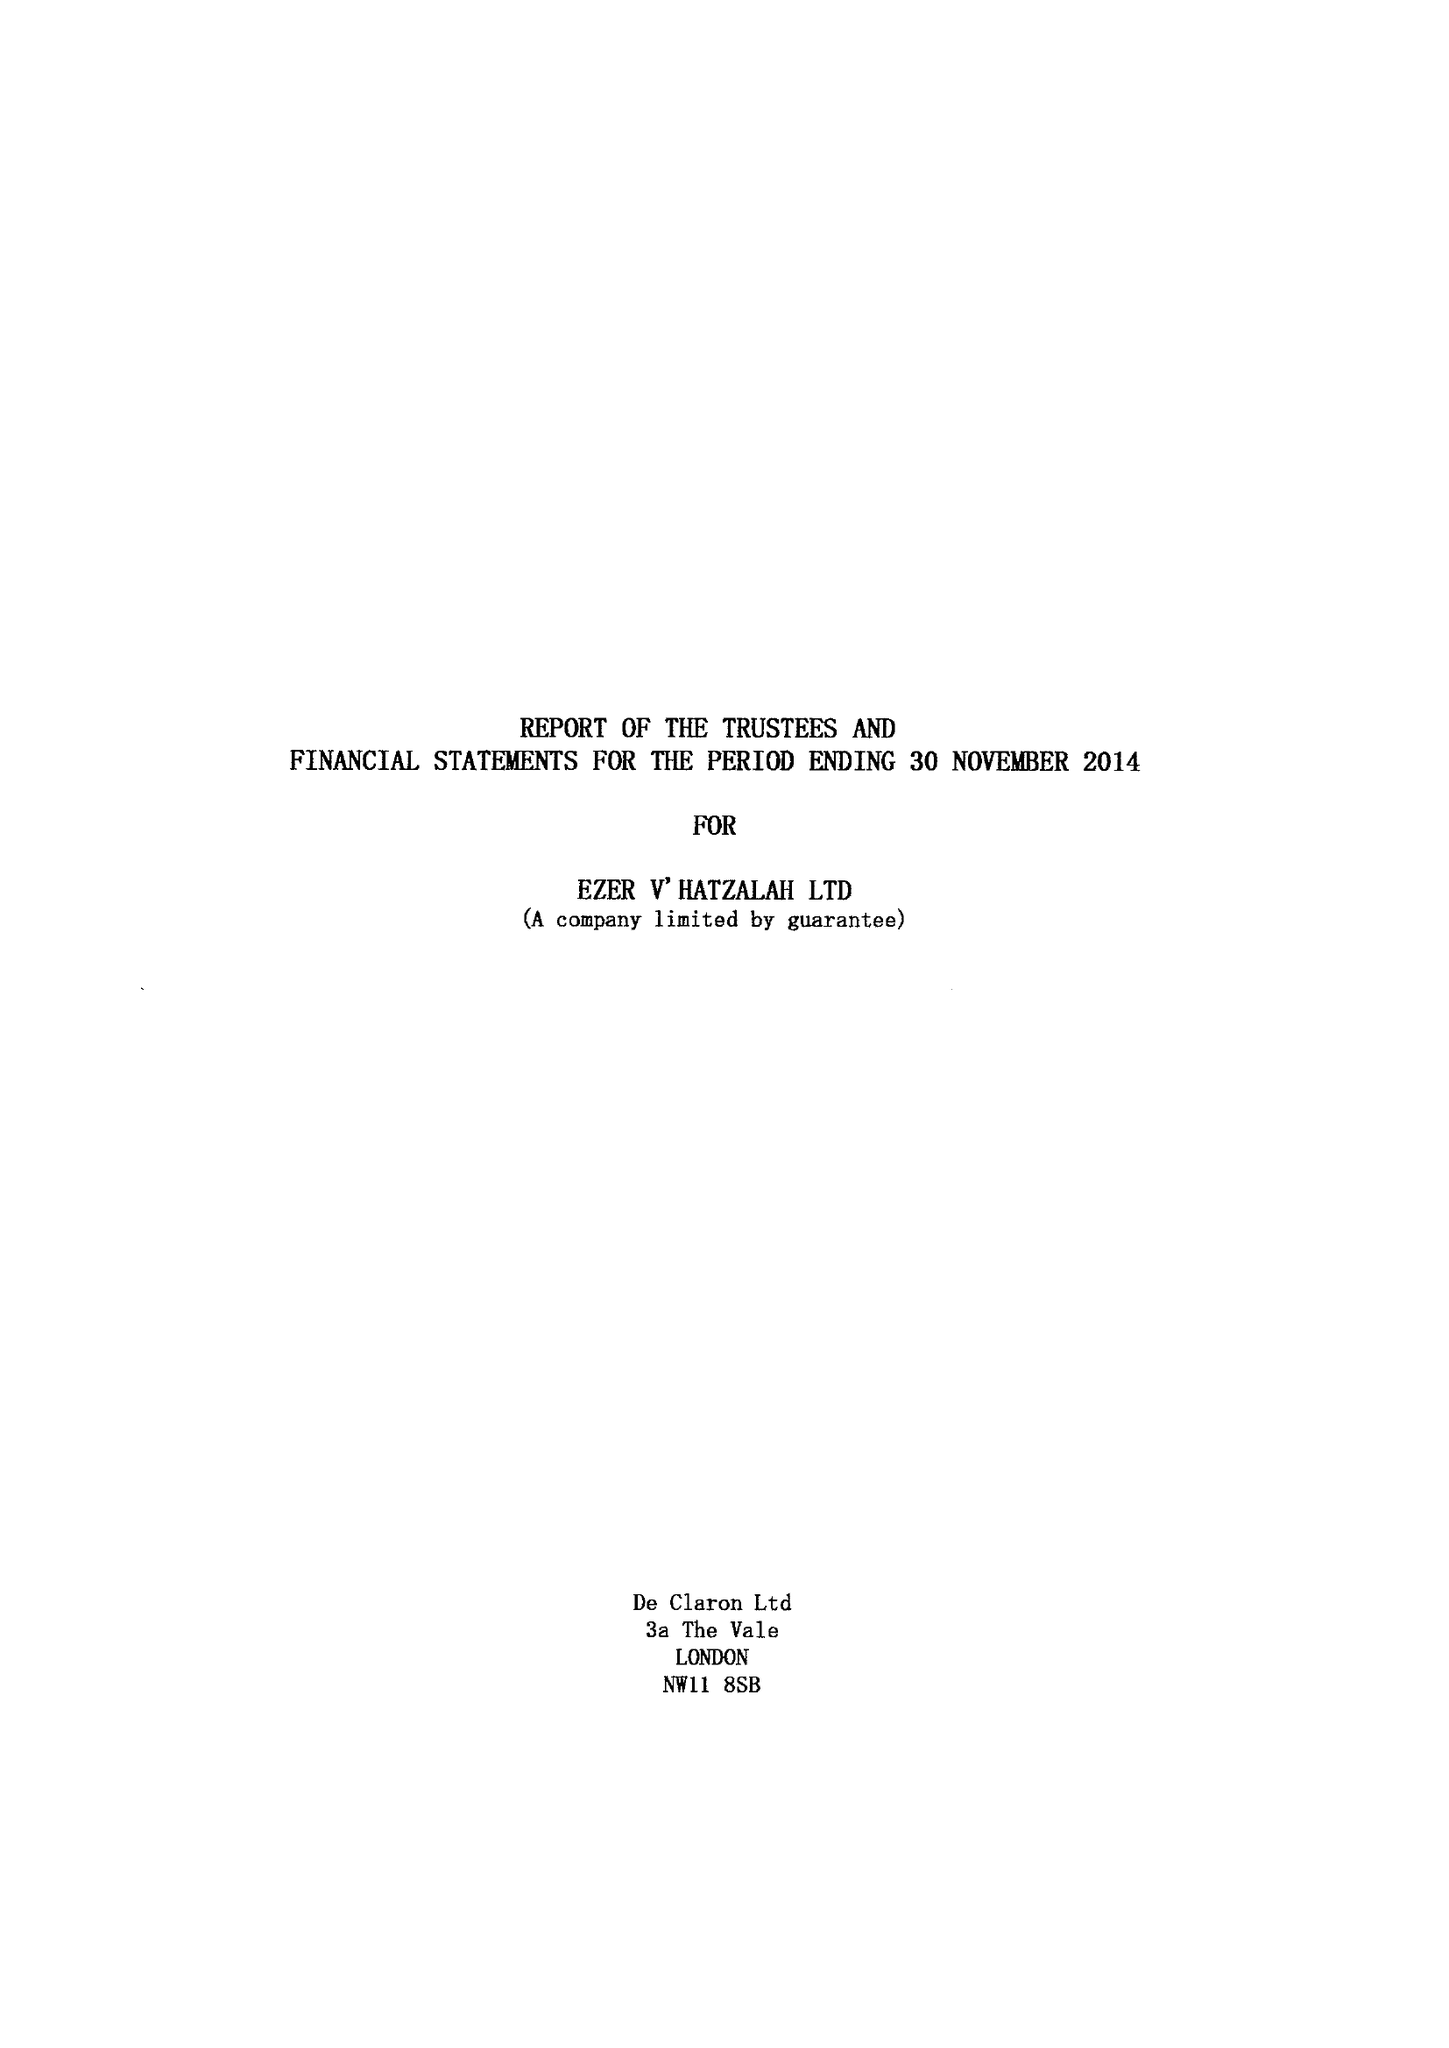What is the value for the charity_name?
Answer the question using a single word or phrase. Ezer V' Hatzalah Ltd. 